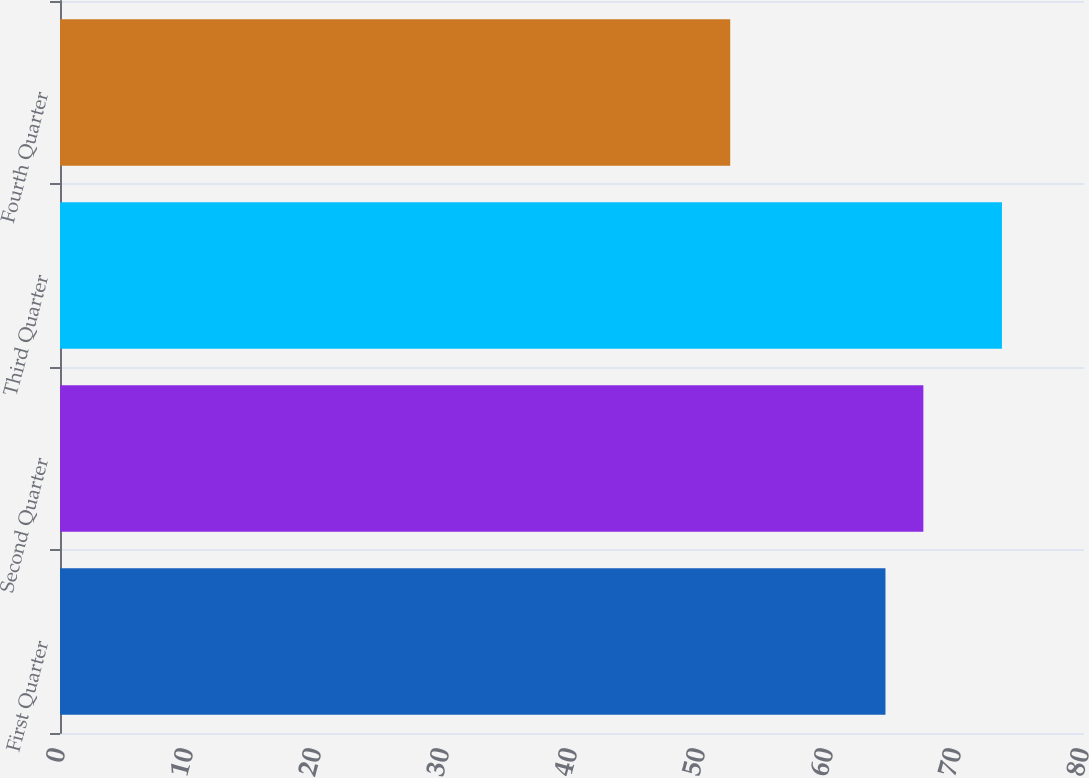<chart> <loc_0><loc_0><loc_500><loc_500><bar_chart><fcel>First Quarter<fcel>Second Quarter<fcel>Third Quarter<fcel>Fourth Quarter<nl><fcel>64.49<fcel>67.45<fcel>73.59<fcel>52.36<nl></chart> 